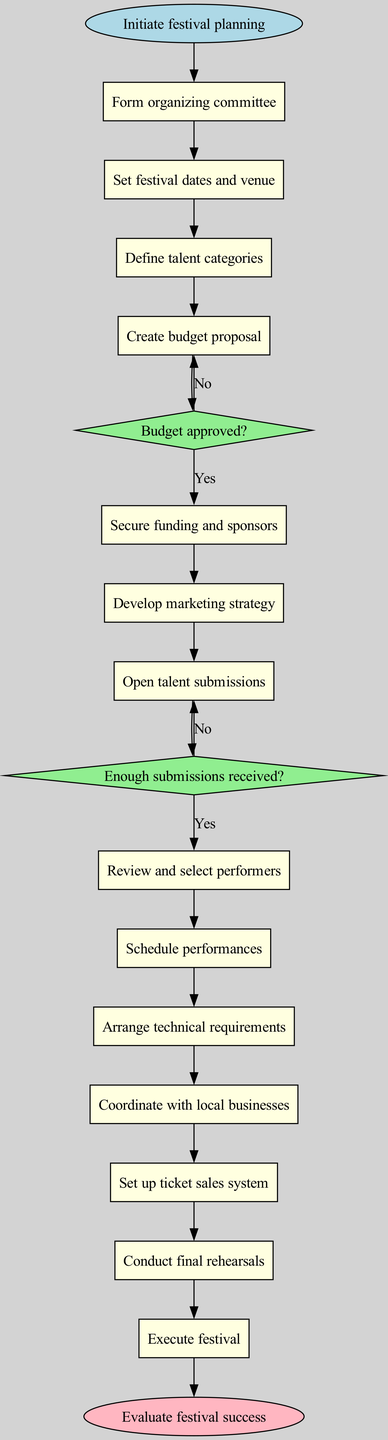What is the starting point of the diagram? The starting point is labeled as "Initiate festival planning", which is the initial action in the flow of the diagram.
Answer: Initiate festival planning How many decision nodes are present in the diagram? There are two decision nodes, which are "Budget approved?" and "Enough submissions received?" Each node represents a point where a choice must be made.
Answer: 2 What activity comes immediately after "Create budget proposal"? According to the flow of the diagram, "Secure funding and sponsors" follows directly after "Create budget proposal", making it the next action.
Answer: Secure funding and sponsors What happens if the budget proposal is not approved? If the budget proposal is not approved (the "no" path from the decision node), the process indicates to "Revise budget proposal", which means a loop back to rework that specific action before proceeding.
Answer: Revise budget proposal Which activity leads to the decision about talent submissions? The activity "Open talent submissions" is the immediate predecessor of the decision node "Enough submissions received?", establishing that it sets up the criteria for the subsequent decision.
Answer: Open talent submissions What is the final step in the festival organization process? The last step listed in the activities is "Evaluate festival success", which concludes the flow of activities and marks the end of the process.
Answer: Evaluate festival success If there are not enough submissions, what is the next action taken? If there are not enough submissions, the flow specifies to "Extend submission deadline", which indicates an extension of time to gather more talent submissions.
Answer: Extend submission deadline How many total activities are displayed in the diagram? There are thirteen activities listed in the diagram, ranging from the initiation of festival planning to the execution of the festival.
Answer: 13 